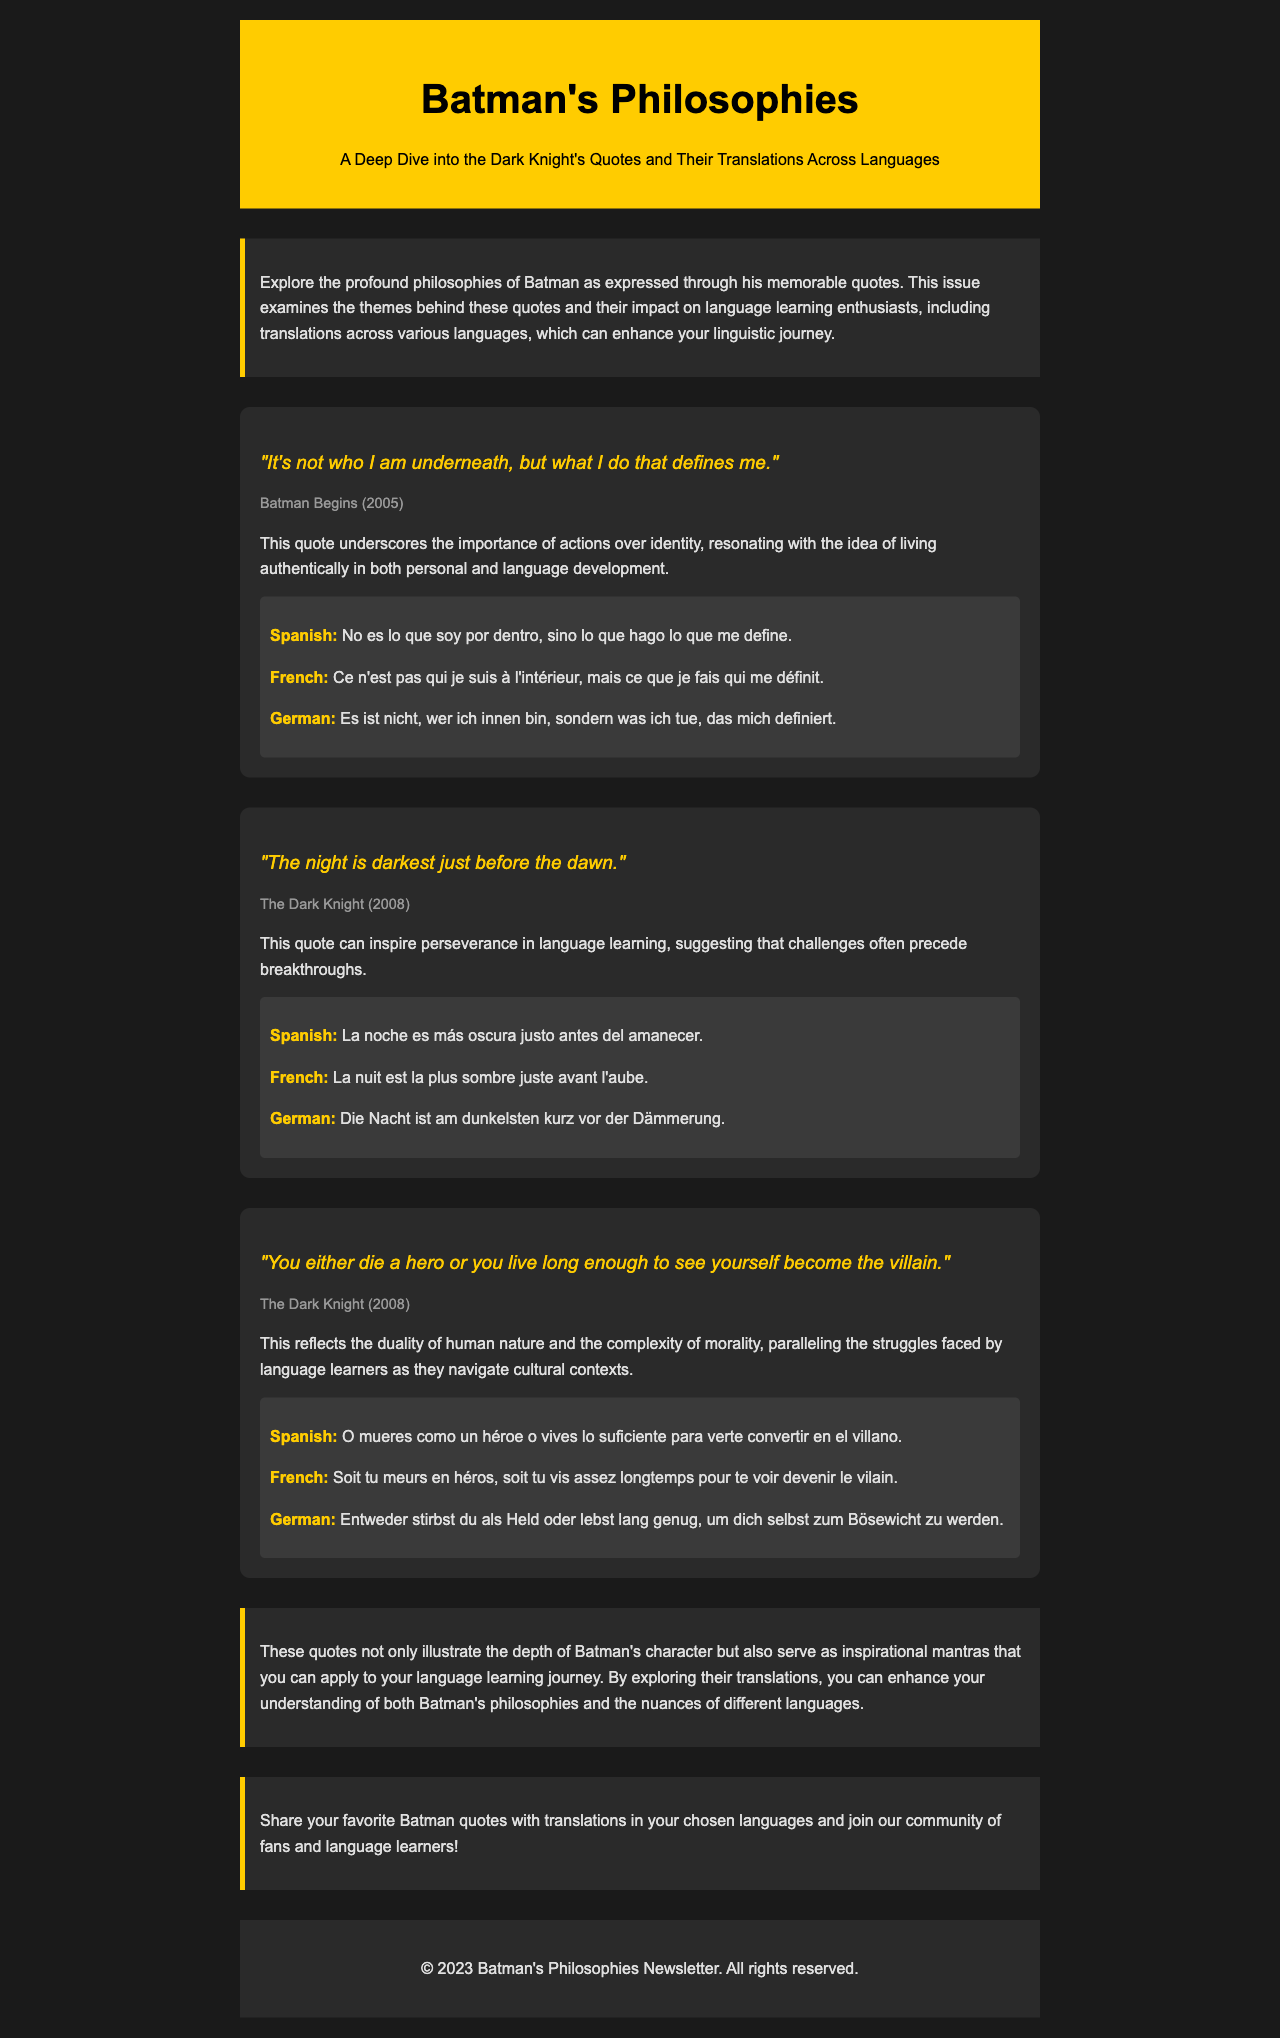What is the title of the newsletter? The title is prominently displayed in the header section of the document.
Answer: Batman's Philosophies Which film features the quote "The night is darkest just before the dawn"? The source of the quote is provided directly below the quote itself.
Answer: The Dark Knight What is a key theme highlighted in Batman's quote about identity? This theme is mentioned in the explanation accompanying the quote, discussing its relevance to personal development.
Answer: Actions over identity How many translations are provided for each quote? The document consistently includes three translations for each featured quote.
Answer: Three What does the conclusion suggest about the relationship between quotes and language learning? The conclusion discusses the inspirational nature of the quotes and their applicability to language learning.
Answer: Enhances understanding Name one of the languages in which the first quote is translated. The translations section lists several languages after the quotes.
Answer: Spanish What does the quote "You either die a hero or you live long enough to see yourself become the villain" reflect? The explanation under this quote highlights its broader meaning regarding human nature.
Answer: Duality of human nature 